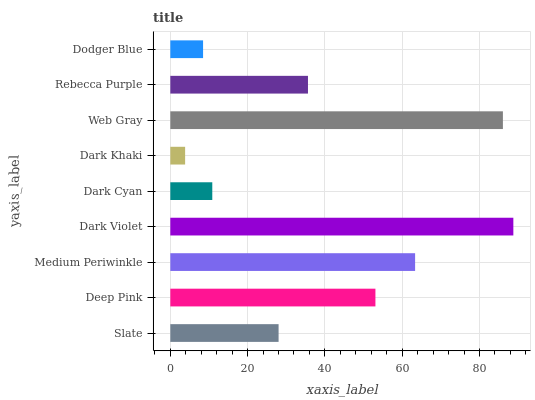Is Dark Khaki the minimum?
Answer yes or no. Yes. Is Dark Violet the maximum?
Answer yes or no. Yes. Is Deep Pink the minimum?
Answer yes or no. No. Is Deep Pink the maximum?
Answer yes or no. No. Is Deep Pink greater than Slate?
Answer yes or no. Yes. Is Slate less than Deep Pink?
Answer yes or no. Yes. Is Slate greater than Deep Pink?
Answer yes or no. No. Is Deep Pink less than Slate?
Answer yes or no. No. Is Rebecca Purple the high median?
Answer yes or no. Yes. Is Rebecca Purple the low median?
Answer yes or no. Yes. Is Dark Violet the high median?
Answer yes or no. No. Is Web Gray the low median?
Answer yes or no. No. 